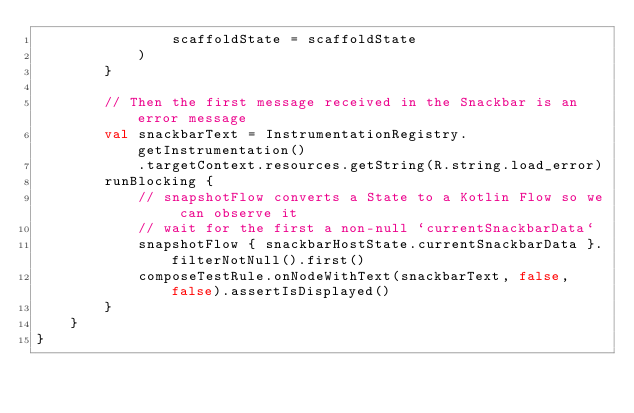<code> <loc_0><loc_0><loc_500><loc_500><_Kotlin_>                scaffoldState = scaffoldState
            )
        }

        // Then the first message received in the Snackbar is an error message
        val snackbarText = InstrumentationRegistry.getInstrumentation()
            .targetContext.resources.getString(R.string.load_error)
        runBlocking {
            // snapshotFlow converts a State to a Kotlin Flow so we can observe it
            // wait for the first a non-null `currentSnackbarData`
            snapshotFlow { snackbarHostState.currentSnackbarData }.filterNotNull().first()
            composeTestRule.onNodeWithText(snackbarText, false, false).assertIsDisplayed()
        }
    }
}
</code> 